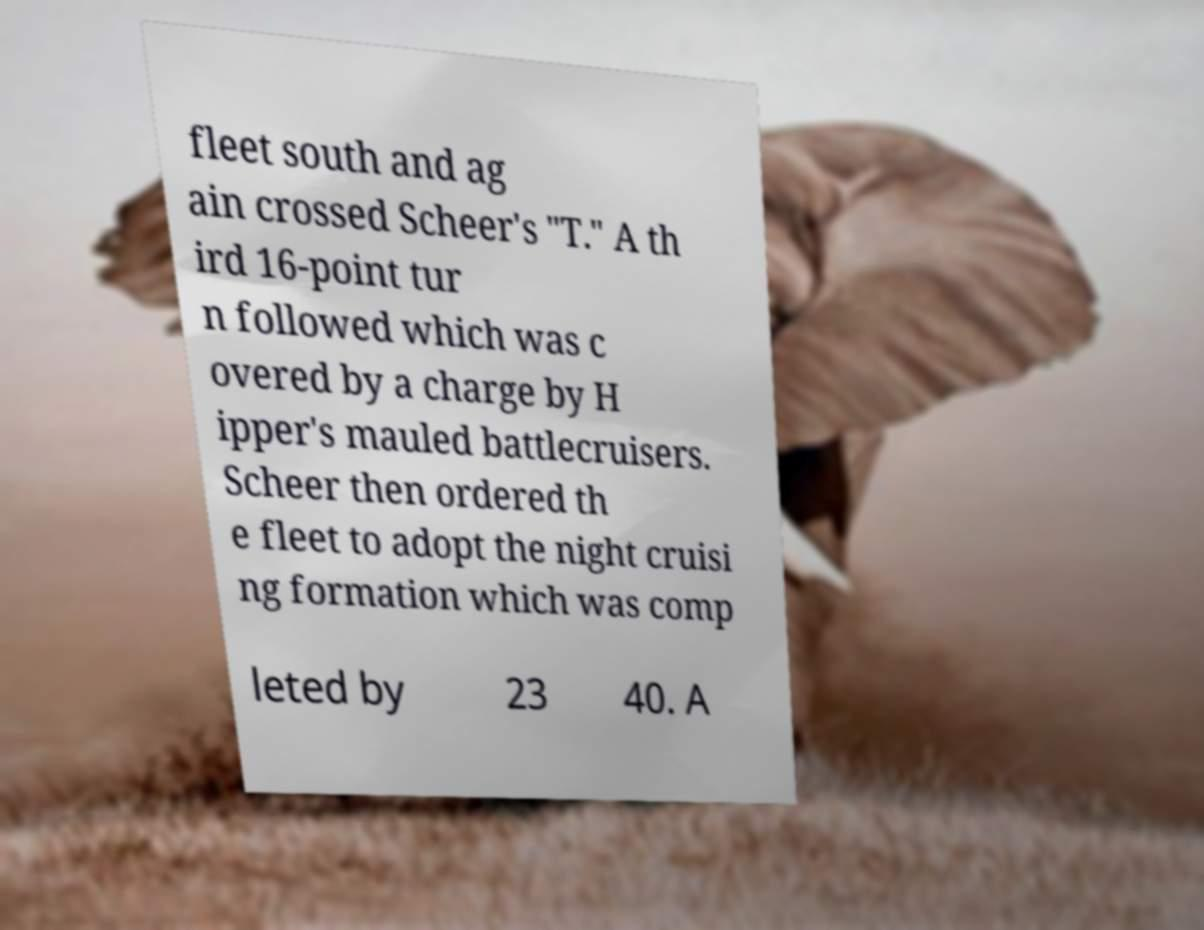Could you assist in decoding the text presented in this image and type it out clearly? fleet south and ag ain crossed Scheer's "T." A th ird 16-point tur n followed which was c overed by a charge by H ipper's mauled battlecruisers. Scheer then ordered th e fleet to adopt the night cruisi ng formation which was comp leted by 23 40. A 